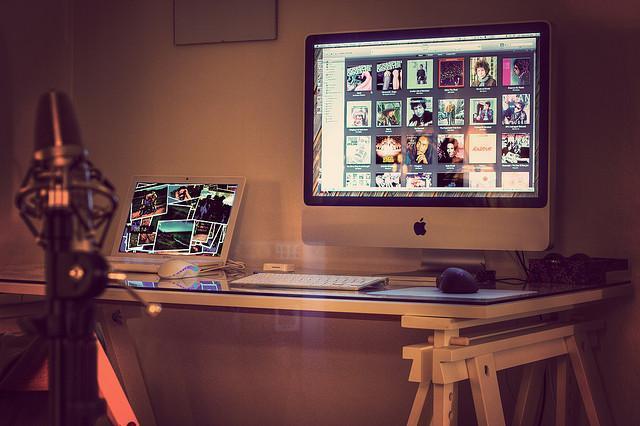How many monitors are there?
Give a very brief answer. 2. How many trucks are crushing on the street?
Give a very brief answer. 0. 